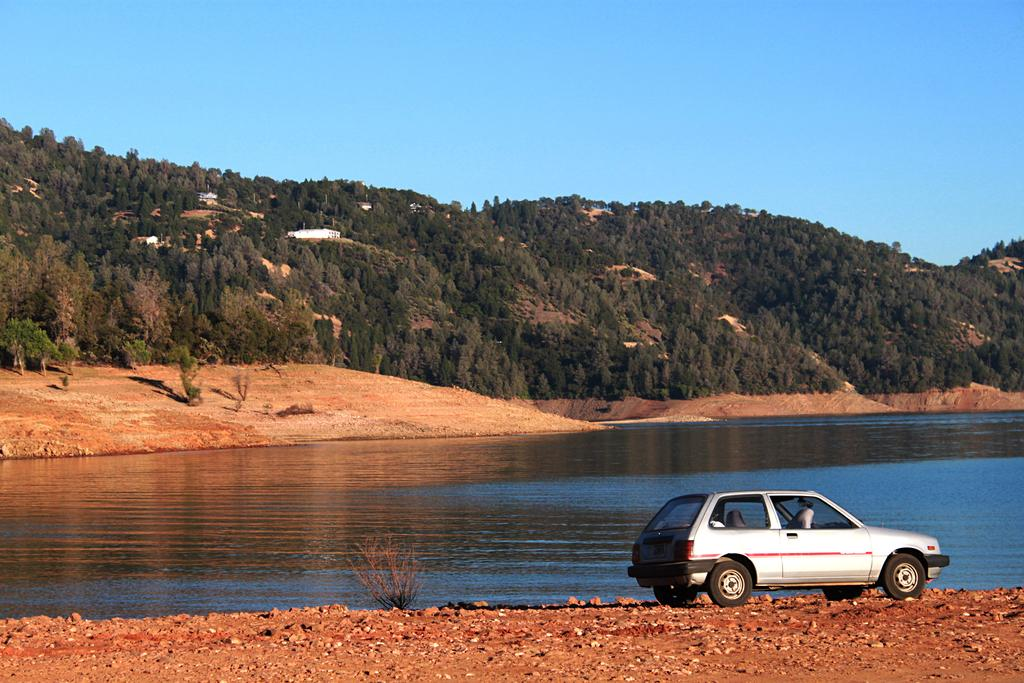What is located at the bottom of the image? There is a vehicle at the bottom of the image. What is behind the vehicle in the image? There is water behind the vehicle. What can be seen in the middle of the image? There are trees and hills in the middle of the image. What is visible at the top of the image? The sky is visible at the top of the image. What type of paste is being used to create the waves in the image? There are no waves present in the image, and therefore no paste is being used. 